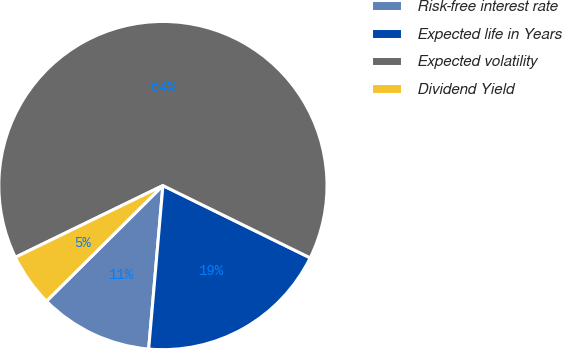Convert chart. <chart><loc_0><loc_0><loc_500><loc_500><pie_chart><fcel>Risk-free interest rate<fcel>Expected life in Years<fcel>Expected volatility<fcel>Dividend Yield<nl><fcel>11.17%<fcel>19.12%<fcel>64.47%<fcel>5.24%<nl></chart> 